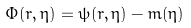<formula> <loc_0><loc_0><loc_500><loc_500>\Phi ( r , \eta ) = \psi ( r , \eta ) - m ( \eta )</formula> 